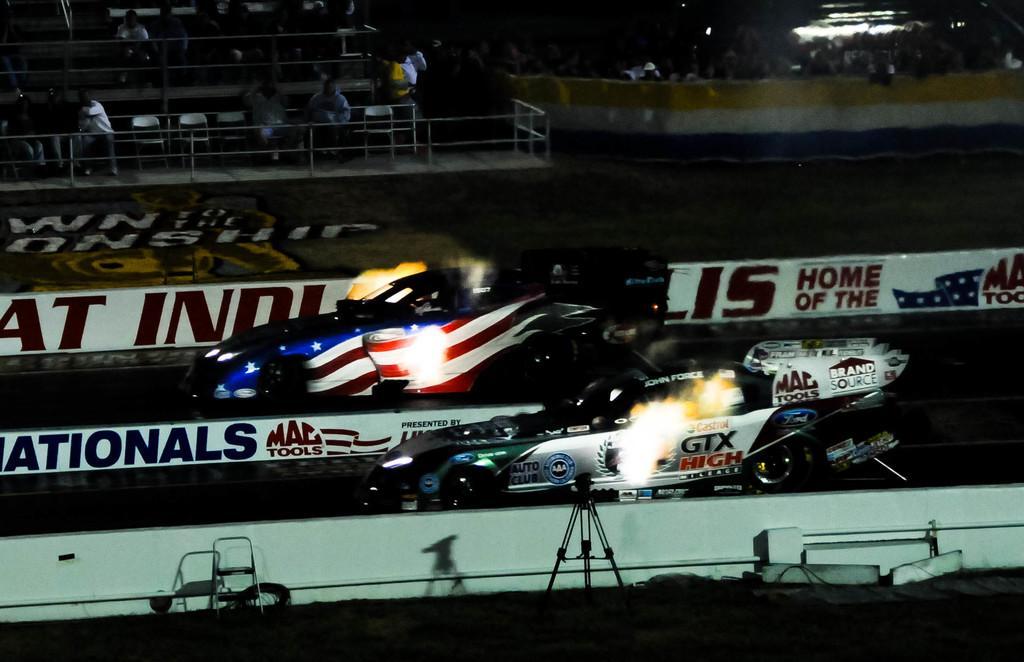Describe this image in one or two sentences. There is a racing competition going on,both the vehicles are moving on the road and there is a white fencing on the either side of the racing path,in the background there is a crowd watching the race. 